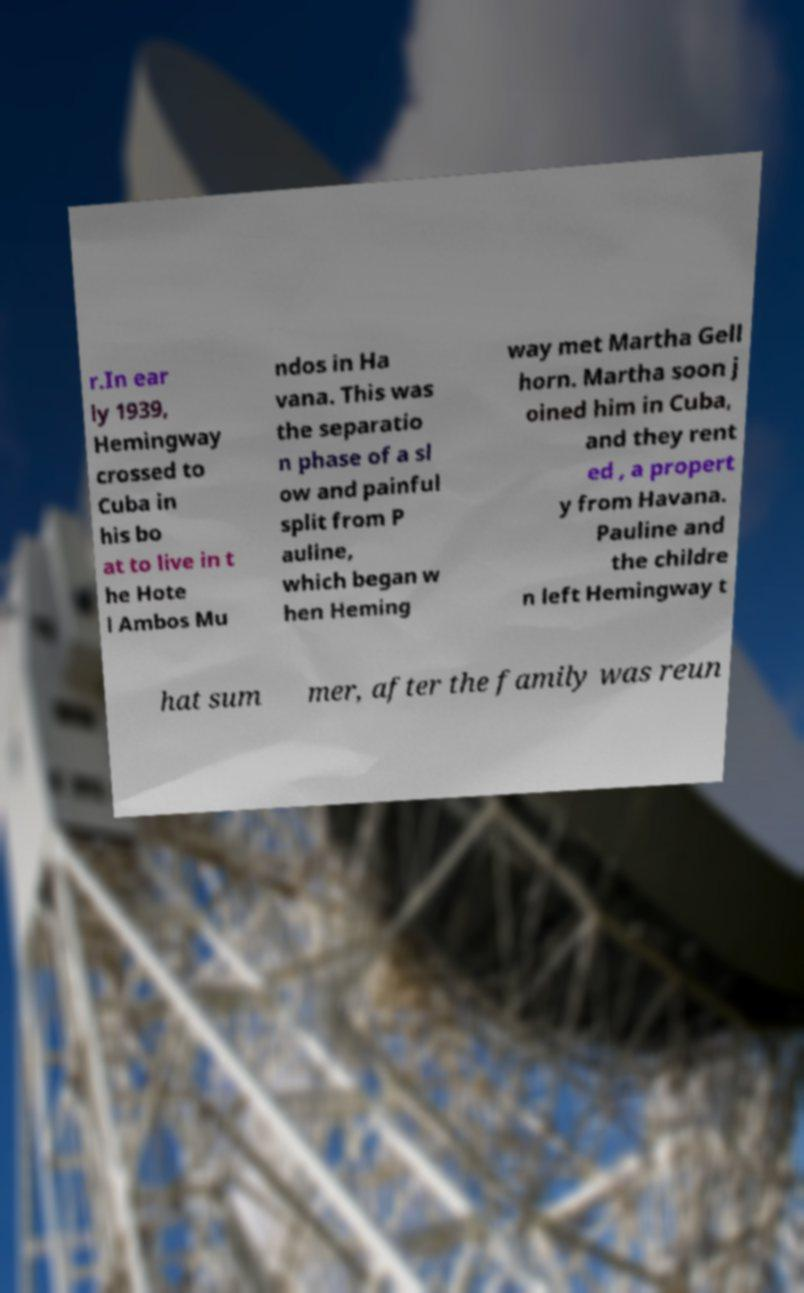Please read and relay the text visible in this image. What does it say? r.In ear ly 1939, Hemingway crossed to Cuba in his bo at to live in t he Hote l Ambos Mu ndos in Ha vana. This was the separatio n phase of a sl ow and painful split from P auline, which began w hen Heming way met Martha Gell horn. Martha soon j oined him in Cuba, and they rent ed , a propert y from Havana. Pauline and the childre n left Hemingway t hat sum mer, after the family was reun 